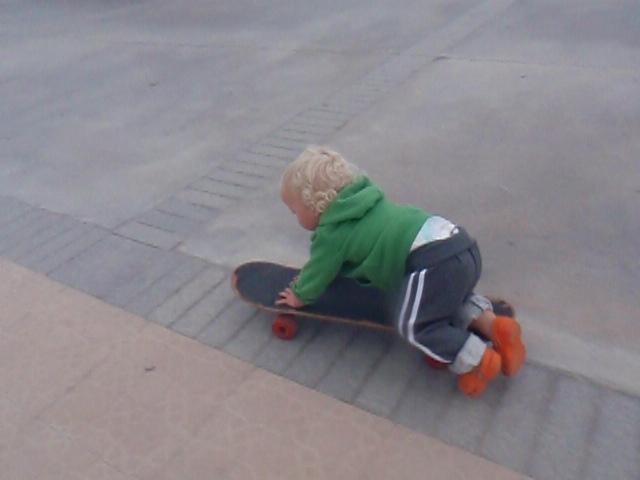Is he good at this sport?
Keep it brief. No. What is on the ground?
Concise answer only. Skateboard. Does the baby know how to ride a skateboard?
Be succinct. No. What kind of pants does the boy have on?
Concise answer only. Sweat. Is he wearing skate shoes?
Be succinct. No. What is the floor covered with?
Write a very short answer. Brick. Is this person a novice?
Answer briefly. Yes. What covers the ground?
Quick response, please. Concrete. What is in his hand?
Be succinct. Skateboard. What is on the boys skateboard?
Keep it brief. Boy. What is the person holding?
Short answer required. Skateboard. How many children are sitting down?
Write a very short answer. 0. What color are the wheels?
Answer briefly. Red. Does the kid look bored?
Answer briefly. No. What is covering the ground?
Write a very short answer. Cement. Was this picture taken at ground level?
Write a very short answer. No. What is the skateboarder doing?
Be succinct. Rolling. What color are his shoes?
Be succinct. Orange. What color is the person wearing?
Short answer required. Green. Is the skater doing a trick?
Be succinct. No. What sport is he playing?
Write a very short answer. Skateboarding. Are there any spectators?
Concise answer only. No. What is this trick called?
Keep it brief. Skateboarding. What color is the skateboard?
Write a very short answer. Black. Is the skateboard moving in this picture?
Keep it brief. Yes. What color are his pants?
Be succinct. Gray. Is this baby alone?
Keep it brief. Yes. What color is the toy skateboard?
Keep it brief. Black. Is the person's knees going to start bleeding?
Write a very short answer. No. Is he wearing the right gear for the sport?
Give a very brief answer. No. What happened to the motorcycle?
Concise answer only. No motorcycle. What color is the person's shoes?
Keep it brief. Orange. What will protect the boy if he falls?
Be succinct. Nothing. How many people are in the photo?
Write a very short answer. 1. What is the white, powdery stuff flying in the air?
Be succinct. Snow. Is he wearing shoes?
Quick response, please. Yes. What is his number?
Keep it brief. 2. What type of activity is taking place?
Keep it brief. Skateboarding. Is the baby riding the skateboard correctly?
Short answer required. No. Is this kid in the air?
Short answer required. No. Is the kid falling?
Be succinct. No. Is the boy off the ground?
Quick response, please. Yes. 